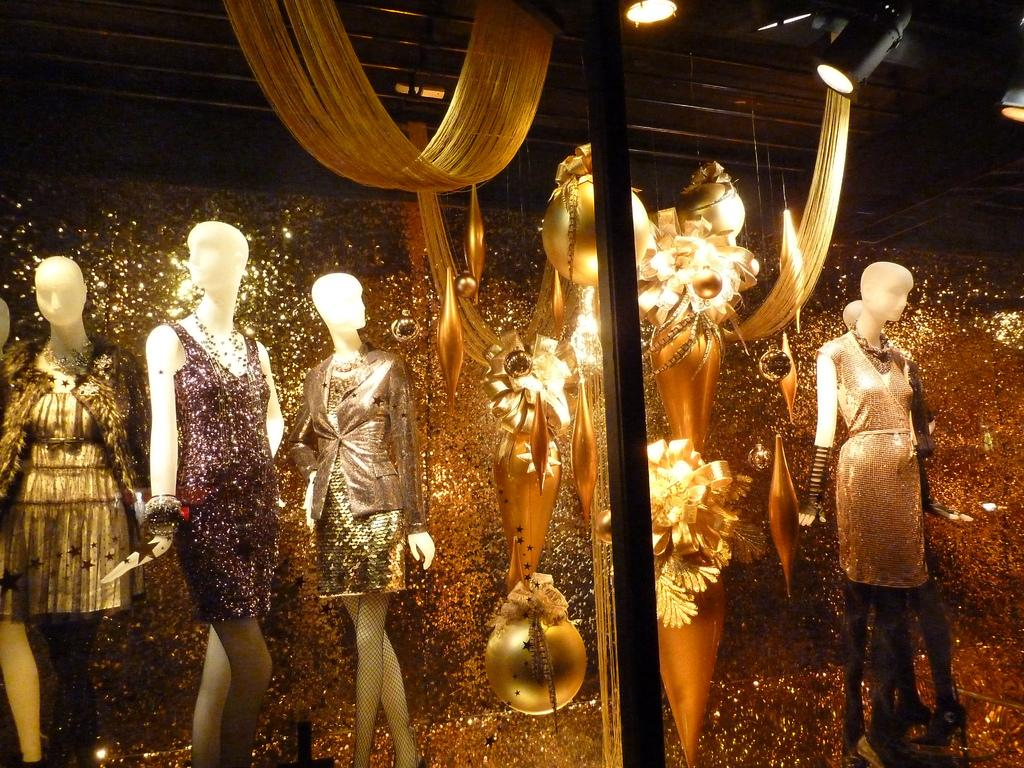What type of figures are in the image? There are mannequins in the image. What are the mannequins wearing? Clothes are visible on the mannequins. What can be seen illuminating the scene? Lights are present in the image. What other objects can be seen in the image besides the mannequins and lights? There are other objects in the image. What type of argument is the baby having with the mannequin in the image? There is no baby present in the image, and therefore no argument can be observed. 